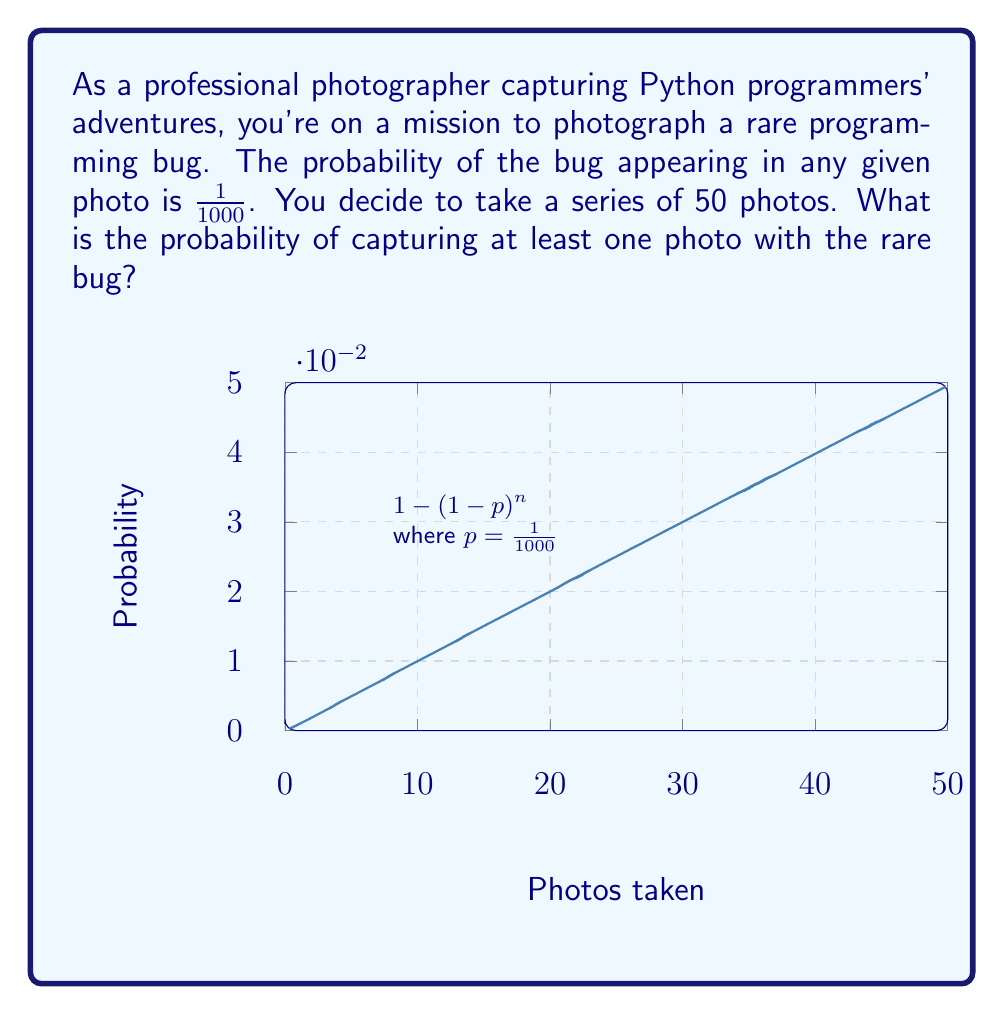Teach me how to tackle this problem. Let's approach this step-by-step:

1) First, let's define our variables:
   $p = 1/1000 = 0.001$ (probability of capturing the bug in a single photo)
   $n = 50$ (number of photos taken)

2) We want to find the probability of capturing at least one photo with the bug. It's easier to calculate the probability of not capturing the bug in any photo and then subtract that from 1.

3) The probability of not capturing the bug in a single photo is:
   $1 - p = 1 - 0.001 = 0.999$

4) For all 50 photos to not have the bug, this needs to happen 50 times in a row. The probability of this is:
   $(0.999)^{50}$

5) Therefore, the probability of capturing at least one photo with the bug is:
   $1 - (0.999)^{50}$

6) Let's calculate this:
   $1 - (0.999)^{50} \approx 1 - 0.9512 = 0.0488$

7) Converting to a percentage:
   $0.0488 \times 100\% = 4.88\%$

Thus, there's approximately a 4.88% chance of capturing at least one photo with the rare bug.
Answer: $1 - (0.999)^{50} \approx 4.88\%$ 